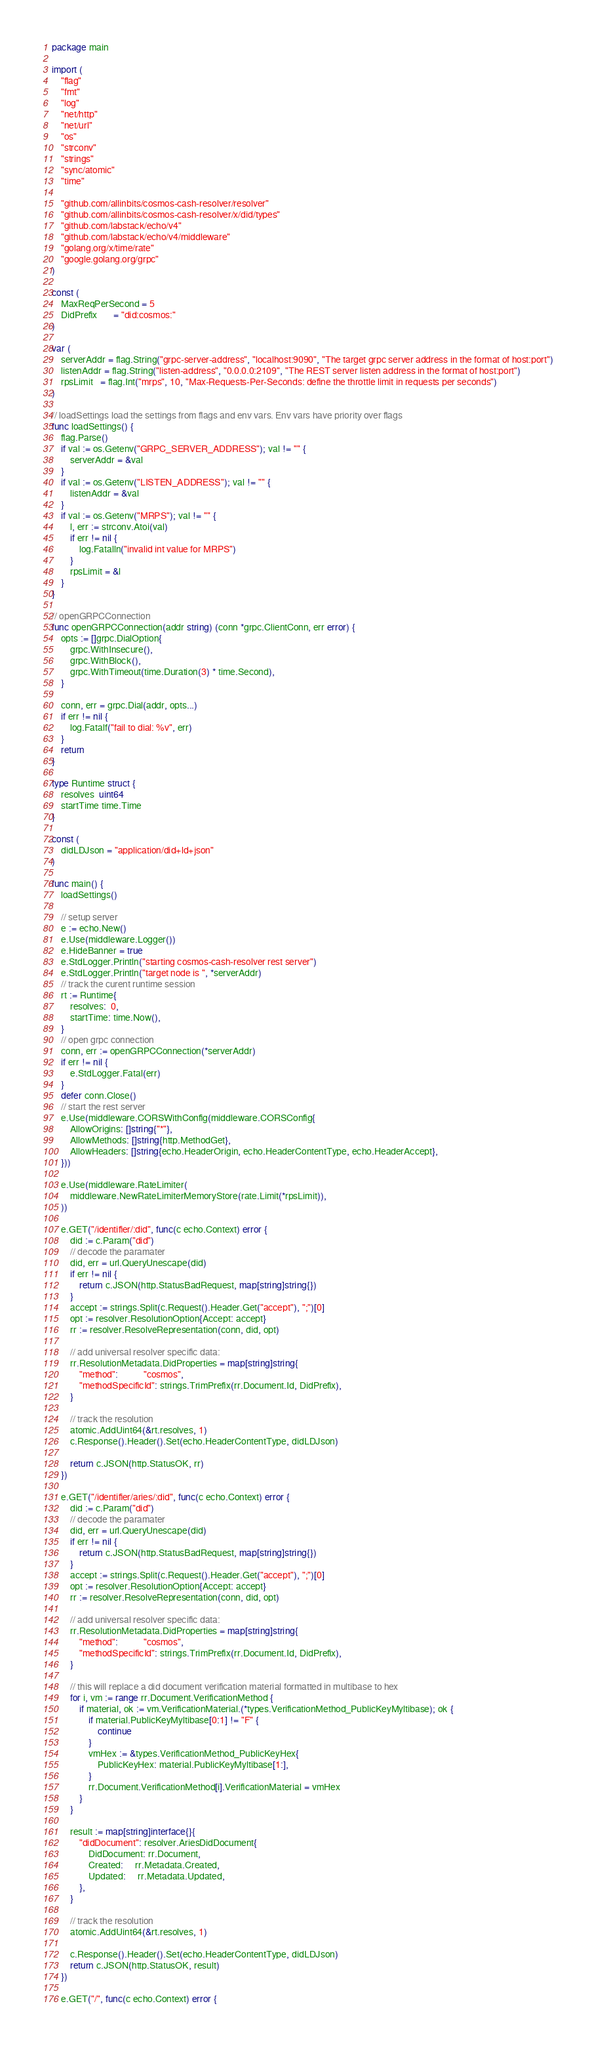Convert code to text. <code><loc_0><loc_0><loc_500><loc_500><_Go_>package main

import (
	"flag"
	"fmt"
	"log"
	"net/http"
	"net/url"
	"os"
	"strconv"
	"strings"
	"sync/atomic"
	"time"

	"github.com/allinbits/cosmos-cash-resolver/resolver"
	"github.com/allinbits/cosmos-cash-resolver/x/did/types"
	"github.com/labstack/echo/v4"
	"github.com/labstack/echo/v4/middleware"
	"golang.org/x/time/rate"
	"google.golang.org/grpc"
)

const (
	MaxReqPerSecond = 5
	DidPrefix       = "did:cosmos:"
)

var (
	serverAddr = flag.String("grpc-server-address", "localhost:9090", "The target grpc server address in the format of host:port")
	listenAddr = flag.String("listen-address", "0.0.0.0:2109", "The REST server listen address in the format of host:port")
	rpsLimit   = flag.Int("mrps", 10, "Max-Requests-Per-Seconds: define the throttle limit in requests per seconds")
)

// loadSettings load the settings from flags and env vars. Env vars have priority over flags
func loadSettings() {
	flag.Parse()
	if val := os.Getenv("GRPC_SERVER_ADDRESS"); val != "" {
		serverAddr = &val
	}
	if val := os.Getenv("LISTEN_ADDRESS"); val != "" {
		listenAddr = &val
	}
	if val := os.Getenv("MRPS"); val != "" {
		l, err := strconv.Atoi(val)
		if err != nil {
			log.Fatalln("invalid int value for MRPS")
		}
		rpsLimit = &l
	}
}

// openGRPCConnection
func openGRPCConnection(addr string) (conn *grpc.ClientConn, err error) {
	opts := []grpc.DialOption{
		grpc.WithInsecure(),
		grpc.WithBlock(),
		grpc.WithTimeout(time.Duration(3) * time.Second),
	}

	conn, err = grpc.Dial(addr, opts...)
	if err != nil {
		log.Fatalf("fail to dial: %v", err)
	}
	return
}

type Runtime struct {
	resolves  uint64
	startTime time.Time
}

const (
	didLDJson = "application/did+ld+json"
)

func main() {
	loadSettings()

	// setup server
	e := echo.New()
	e.Use(middleware.Logger())
	e.HideBanner = true
	e.StdLogger.Println("starting cosmos-cash-resolver rest server")
	e.StdLogger.Println("target node is ", *serverAddr)
	// track the curent runtime session
	rt := Runtime{
		resolves:  0,
		startTime: time.Now(),
	}
	// open grpc connection
	conn, err := openGRPCConnection(*serverAddr)
	if err != nil {
		e.StdLogger.Fatal(err)
	}
	defer conn.Close()
	// start the rest server
	e.Use(middleware.CORSWithConfig(middleware.CORSConfig{
		AllowOrigins: []string{"*"},
		AllowMethods: []string{http.MethodGet},
		AllowHeaders: []string{echo.HeaderOrigin, echo.HeaderContentType, echo.HeaderAccept},
	}))

	e.Use(middleware.RateLimiter(
		middleware.NewRateLimiterMemoryStore(rate.Limit(*rpsLimit)),
	))

	e.GET("/identifier/:did", func(c echo.Context) error {
		did := c.Param("did")
		// decode the paramater
		did, err = url.QueryUnescape(did)
		if err != nil {
			return c.JSON(http.StatusBadRequest, map[string]string{})
		}
		accept := strings.Split(c.Request().Header.Get("accept"), ";")[0]
		opt := resolver.ResolutionOption{Accept: accept}
		rr := resolver.ResolveRepresentation(conn, did, opt)

		// add universal resolver specific data:
		rr.ResolutionMetadata.DidProperties = map[string]string{
			"method":           "cosmos",
			"methodSpecificId": strings.TrimPrefix(rr.Document.Id, DidPrefix),
		}

		// track the resolution
		atomic.AddUint64(&rt.resolves, 1)
		c.Response().Header().Set(echo.HeaderContentType, didLDJson)

		return c.JSON(http.StatusOK, rr)
	})

	e.GET("/identifier/aries/:did", func(c echo.Context) error {
		did := c.Param("did")
		// decode the paramater
		did, err = url.QueryUnescape(did)
		if err != nil {
			return c.JSON(http.StatusBadRequest, map[string]string{})
		}
		accept := strings.Split(c.Request().Header.Get("accept"), ";")[0]
		opt := resolver.ResolutionOption{Accept: accept}
		rr := resolver.ResolveRepresentation(conn, did, opt)

		// add universal resolver specific data:
		rr.ResolutionMetadata.DidProperties = map[string]string{
			"method":           "cosmos",
			"methodSpecificId": strings.TrimPrefix(rr.Document.Id, DidPrefix),
		}

		// this will replace a did document verification material formatted in multibase to hex
		for i, vm := range rr.Document.VerificationMethod {
			if material, ok := vm.VerificationMaterial.(*types.VerificationMethod_PublicKeyMyltibase); ok {
				if material.PublicKeyMyltibase[0:1] != "F" {
					continue
				}
				vmHex := &types.VerificationMethod_PublicKeyHex{
					PublicKeyHex: material.PublicKeyMyltibase[1:],
				}
				rr.Document.VerificationMethod[i].VerificationMaterial = vmHex
			}
		}

		result := map[string]interface{}{
			"didDocument": resolver.AriesDidDocument{
				DidDocument: rr.Document,
				Created:     rr.Metadata.Created,
				Updated:     rr.Metadata.Updated,
			},
		}

		// track the resolution
		atomic.AddUint64(&rt.resolves, 1)

		c.Response().Header().Set(echo.HeaderContentType, didLDJson)
		return c.JSON(http.StatusOK, result)
	})

	e.GET("/", func(c echo.Context) error {</code> 